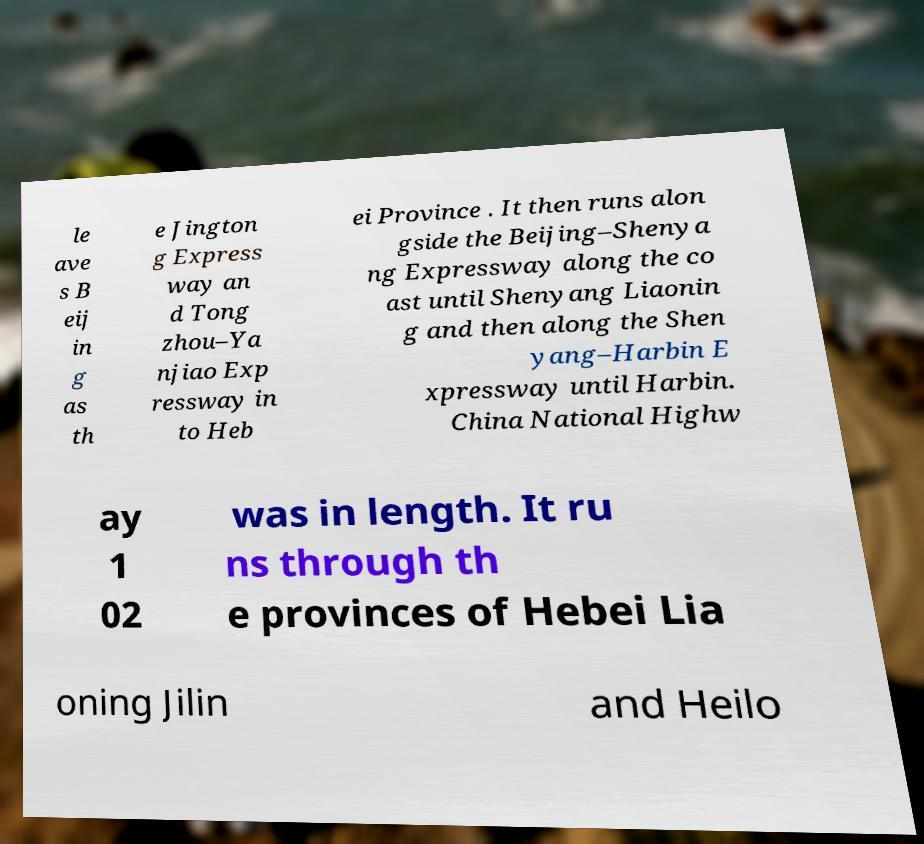I need the written content from this picture converted into text. Can you do that? le ave s B eij in g as th e Jington g Express way an d Tong zhou–Ya njiao Exp ressway in to Heb ei Province . It then runs alon gside the Beijing–Shenya ng Expressway along the co ast until Shenyang Liaonin g and then along the Shen yang–Harbin E xpressway until Harbin. China National Highw ay 1 02 was in length. It ru ns through th e provinces of Hebei Lia oning Jilin and Heilo 